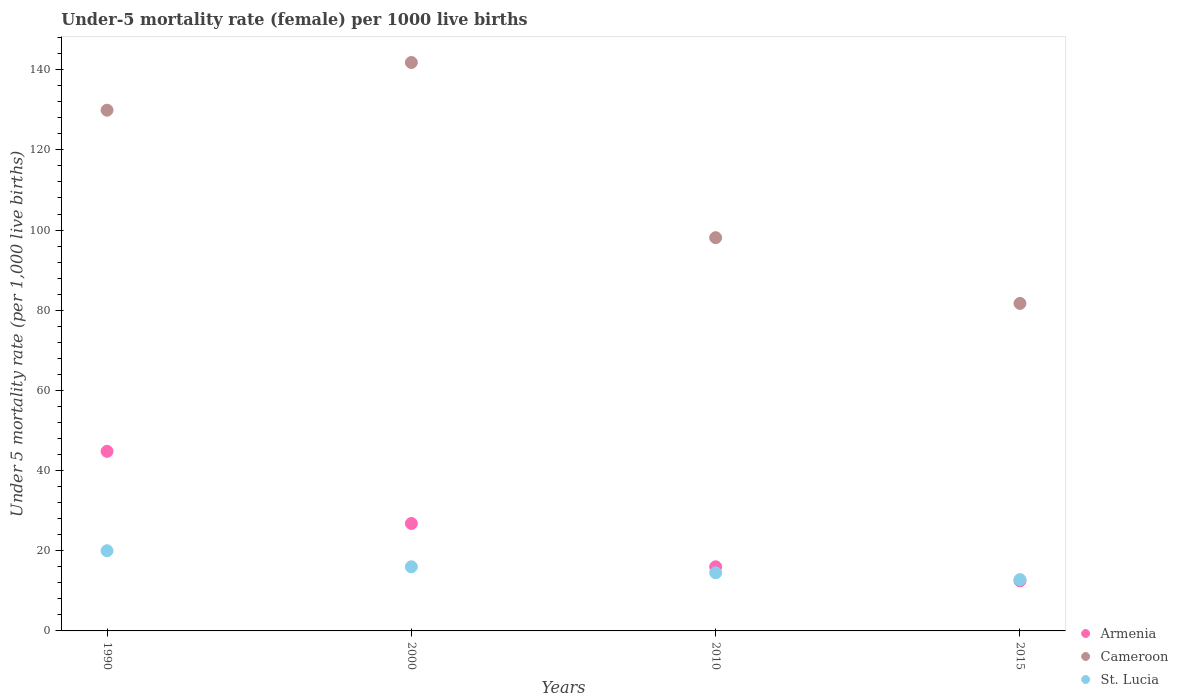Is the number of dotlines equal to the number of legend labels?
Make the answer very short. Yes. What is the under-five mortality rate in Armenia in 2010?
Give a very brief answer. 16. Across all years, what is the maximum under-five mortality rate in Cameroon?
Make the answer very short. 141.8. In which year was the under-five mortality rate in Armenia minimum?
Keep it short and to the point. 2015. What is the total under-five mortality rate in Armenia in the graph?
Your answer should be very brief. 100.1. What is the difference between the under-five mortality rate in St. Lucia in 2000 and that in 2015?
Give a very brief answer. 3.2. What is the difference between the under-five mortality rate in Armenia in 1990 and the under-five mortality rate in Cameroon in 2010?
Offer a terse response. -53.3. What is the average under-five mortality rate in Armenia per year?
Offer a terse response. 25.02. In the year 2010, what is the difference between the under-five mortality rate in Armenia and under-five mortality rate in St. Lucia?
Provide a short and direct response. 1.5. What is the ratio of the under-five mortality rate in Armenia in 2000 to that in 2015?
Make the answer very short. 2.14. What is the difference between the highest and the lowest under-five mortality rate in St. Lucia?
Your answer should be compact. 7.2. In how many years, is the under-five mortality rate in Cameroon greater than the average under-five mortality rate in Cameroon taken over all years?
Your answer should be very brief. 2. Is the sum of the under-five mortality rate in Armenia in 2000 and 2010 greater than the maximum under-five mortality rate in St. Lucia across all years?
Your response must be concise. Yes. Is it the case that in every year, the sum of the under-five mortality rate in St. Lucia and under-five mortality rate in Armenia  is greater than the under-five mortality rate in Cameroon?
Keep it short and to the point. No. Does the under-five mortality rate in St. Lucia monotonically increase over the years?
Give a very brief answer. No. How many years are there in the graph?
Your answer should be very brief. 4. What is the difference between two consecutive major ticks on the Y-axis?
Your answer should be very brief. 20. Does the graph contain any zero values?
Offer a terse response. No. Does the graph contain grids?
Ensure brevity in your answer.  No. Where does the legend appear in the graph?
Offer a very short reply. Bottom right. How are the legend labels stacked?
Offer a very short reply. Vertical. What is the title of the graph?
Offer a very short reply. Under-5 mortality rate (female) per 1000 live births. Does "Nicaragua" appear as one of the legend labels in the graph?
Your response must be concise. No. What is the label or title of the Y-axis?
Your response must be concise. Under 5 mortality rate (per 1,0 live births). What is the Under 5 mortality rate (per 1,000 live births) in Armenia in 1990?
Ensure brevity in your answer.  44.8. What is the Under 5 mortality rate (per 1,000 live births) of Cameroon in 1990?
Ensure brevity in your answer.  129.9. What is the Under 5 mortality rate (per 1,000 live births) of Armenia in 2000?
Provide a short and direct response. 26.8. What is the Under 5 mortality rate (per 1,000 live births) in Cameroon in 2000?
Your answer should be compact. 141.8. What is the Under 5 mortality rate (per 1,000 live births) of St. Lucia in 2000?
Make the answer very short. 16. What is the Under 5 mortality rate (per 1,000 live births) of Armenia in 2010?
Provide a short and direct response. 16. What is the Under 5 mortality rate (per 1,000 live births) in Cameroon in 2010?
Keep it short and to the point. 98.1. What is the Under 5 mortality rate (per 1,000 live births) in Armenia in 2015?
Give a very brief answer. 12.5. What is the Under 5 mortality rate (per 1,000 live births) of Cameroon in 2015?
Your answer should be compact. 81.7. Across all years, what is the maximum Under 5 mortality rate (per 1,000 live births) of Armenia?
Keep it short and to the point. 44.8. Across all years, what is the maximum Under 5 mortality rate (per 1,000 live births) in Cameroon?
Provide a succinct answer. 141.8. Across all years, what is the maximum Under 5 mortality rate (per 1,000 live births) of St. Lucia?
Offer a terse response. 20. Across all years, what is the minimum Under 5 mortality rate (per 1,000 live births) in Armenia?
Your answer should be very brief. 12.5. Across all years, what is the minimum Under 5 mortality rate (per 1,000 live births) of Cameroon?
Provide a short and direct response. 81.7. Across all years, what is the minimum Under 5 mortality rate (per 1,000 live births) in St. Lucia?
Your answer should be compact. 12.8. What is the total Under 5 mortality rate (per 1,000 live births) in Armenia in the graph?
Your answer should be very brief. 100.1. What is the total Under 5 mortality rate (per 1,000 live births) of Cameroon in the graph?
Provide a short and direct response. 451.5. What is the total Under 5 mortality rate (per 1,000 live births) of St. Lucia in the graph?
Offer a terse response. 63.3. What is the difference between the Under 5 mortality rate (per 1,000 live births) in Armenia in 1990 and that in 2010?
Your answer should be compact. 28.8. What is the difference between the Under 5 mortality rate (per 1,000 live births) in Cameroon in 1990 and that in 2010?
Your answer should be very brief. 31.8. What is the difference between the Under 5 mortality rate (per 1,000 live births) in St. Lucia in 1990 and that in 2010?
Make the answer very short. 5.5. What is the difference between the Under 5 mortality rate (per 1,000 live births) of Armenia in 1990 and that in 2015?
Provide a short and direct response. 32.3. What is the difference between the Under 5 mortality rate (per 1,000 live births) in Cameroon in 1990 and that in 2015?
Give a very brief answer. 48.2. What is the difference between the Under 5 mortality rate (per 1,000 live births) of Cameroon in 2000 and that in 2010?
Keep it short and to the point. 43.7. What is the difference between the Under 5 mortality rate (per 1,000 live births) in St. Lucia in 2000 and that in 2010?
Provide a succinct answer. 1.5. What is the difference between the Under 5 mortality rate (per 1,000 live births) in Armenia in 2000 and that in 2015?
Provide a short and direct response. 14.3. What is the difference between the Under 5 mortality rate (per 1,000 live births) in Cameroon in 2000 and that in 2015?
Give a very brief answer. 60.1. What is the difference between the Under 5 mortality rate (per 1,000 live births) in St. Lucia in 2000 and that in 2015?
Keep it short and to the point. 3.2. What is the difference between the Under 5 mortality rate (per 1,000 live births) in Armenia in 2010 and that in 2015?
Make the answer very short. 3.5. What is the difference between the Under 5 mortality rate (per 1,000 live births) of Armenia in 1990 and the Under 5 mortality rate (per 1,000 live births) of Cameroon in 2000?
Your answer should be compact. -97. What is the difference between the Under 5 mortality rate (per 1,000 live births) in Armenia in 1990 and the Under 5 mortality rate (per 1,000 live births) in St. Lucia in 2000?
Make the answer very short. 28.8. What is the difference between the Under 5 mortality rate (per 1,000 live births) in Cameroon in 1990 and the Under 5 mortality rate (per 1,000 live births) in St. Lucia in 2000?
Ensure brevity in your answer.  113.9. What is the difference between the Under 5 mortality rate (per 1,000 live births) in Armenia in 1990 and the Under 5 mortality rate (per 1,000 live births) in Cameroon in 2010?
Provide a short and direct response. -53.3. What is the difference between the Under 5 mortality rate (per 1,000 live births) in Armenia in 1990 and the Under 5 mortality rate (per 1,000 live births) in St. Lucia in 2010?
Ensure brevity in your answer.  30.3. What is the difference between the Under 5 mortality rate (per 1,000 live births) in Cameroon in 1990 and the Under 5 mortality rate (per 1,000 live births) in St. Lucia in 2010?
Offer a terse response. 115.4. What is the difference between the Under 5 mortality rate (per 1,000 live births) of Armenia in 1990 and the Under 5 mortality rate (per 1,000 live births) of Cameroon in 2015?
Offer a very short reply. -36.9. What is the difference between the Under 5 mortality rate (per 1,000 live births) in Armenia in 1990 and the Under 5 mortality rate (per 1,000 live births) in St. Lucia in 2015?
Make the answer very short. 32. What is the difference between the Under 5 mortality rate (per 1,000 live births) in Cameroon in 1990 and the Under 5 mortality rate (per 1,000 live births) in St. Lucia in 2015?
Your answer should be compact. 117.1. What is the difference between the Under 5 mortality rate (per 1,000 live births) of Armenia in 2000 and the Under 5 mortality rate (per 1,000 live births) of Cameroon in 2010?
Your answer should be compact. -71.3. What is the difference between the Under 5 mortality rate (per 1,000 live births) in Cameroon in 2000 and the Under 5 mortality rate (per 1,000 live births) in St. Lucia in 2010?
Offer a very short reply. 127.3. What is the difference between the Under 5 mortality rate (per 1,000 live births) in Armenia in 2000 and the Under 5 mortality rate (per 1,000 live births) in Cameroon in 2015?
Offer a very short reply. -54.9. What is the difference between the Under 5 mortality rate (per 1,000 live births) of Armenia in 2000 and the Under 5 mortality rate (per 1,000 live births) of St. Lucia in 2015?
Your answer should be very brief. 14. What is the difference between the Under 5 mortality rate (per 1,000 live births) in Cameroon in 2000 and the Under 5 mortality rate (per 1,000 live births) in St. Lucia in 2015?
Your answer should be very brief. 129. What is the difference between the Under 5 mortality rate (per 1,000 live births) of Armenia in 2010 and the Under 5 mortality rate (per 1,000 live births) of Cameroon in 2015?
Your answer should be very brief. -65.7. What is the difference between the Under 5 mortality rate (per 1,000 live births) of Cameroon in 2010 and the Under 5 mortality rate (per 1,000 live births) of St. Lucia in 2015?
Offer a very short reply. 85.3. What is the average Under 5 mortality rate (per 1,000 live births) in Armenia per year?
Offer a terse response. 25.02. What is the average Under 5 mortality rate (per 1,000 live births) of Cameroon per year?
Keep it short and to the point. 112.88. What is the average Under 5 mortality rate (per 1,000 live births) of St. Lucia per year?
Make the answer very short. 15.82. In the year 1990, what is the difference between the Under 5 mortality rate (per 1,000 live births) in Armenia and Under 5 mortality rate (per 1,000 live births) in Cameroon?
Offer a terse response. -85.1. In the year 1990, what is the difference between the Under 5 mortality rate (per 1,000 live births) of Armenia and Under 5 mortality rate (per 1,000 live births) of St. Lucia?
Keep it short and to the point. 24.8. In the year 1990, what is the difference between the Under 5 mortality rate (per 1,000 live births) in Cameroon and Under 5 mortality rate (per 1,000 live births) in St. Lucia?
Offer a terse response. 109.9. In the year 2000, what is the difference between the Under 5 mortality rate (per 1,000 live births) of Armenia and Under 5 mortality rate (per 1,000 live births) of Cameroon?
Give a very brief answer. -115. In the year 2000, what is the difference between the Under 5 mortality rate (per 1,000 live births) in Armenia and Under 5 mortality rate (per 1,000 live births) in St. Lucia?
Offer a very short reply. 10.8. In the year 2000, what is the difference between the Under 5 mortality rate (per 1,000 live births) of Cameroon and Under 5 mortality rate (per 1,000 live births) of St. Lucia?
Make the answer very short. 125.8. In the year 2010, what is the difference between the Under 5 mortality rate (per 1,000 live births) of Armenia and Under 5 mortality rate (per 1,000 live births) of Cameroon?
Offer a very short reply. -82.1. In the year 2010, what is the difference between the Under 5 mortality rate (per 1,000 live births) in Armenia and Under 5 mortality rate (per 1,000 live births) in St. Lucia?
Ensure brevity in your answer.  1.5. In the year 2010, what is the difference between the Under 5 mortality rate (per 1,000 live births) in Cameroon and Under 5 mortality rate (per 1,000 live births) in St. Lucia?
Your response must be concise. 83.6. In the year 2015, what is the difference between the Under 5 mortality rate (per 1,000 live births) in Armenia and Under 5 mortality rate (per 1,000 live births) in Cameroon?
Ensure brevity in your answer.  -69.2. In the year 2015, what is the difference between the Under 5 mortality rate (per 1,000 live births) in Cameroon and Under 5 mortality rate (per 1,000 live births) in St. Lucia?
Offer a terse response. 68.9. What is the ratio of the Under 5 mortality rate (per 1,000 live births) of Armenia in 1990 to that in 2000?
Make the answer very short. 1.67. What is the ratio of the Under 5 mortality rate (per 1,000 live births) of Cameroon in 1990 to that in 2000?
Offer a very short reply. 0.92. What is the ratio of the Under 5 mortality rate (per 1,000 live births) of Cameroon in 1990 to that in 2010?
Ensure brevity in your answer.  1.32. What is the ratio of the Under 5 mortality rate (per 1,000 live births) in St. Lucia in 1990 to that in 2010?
Offer a very short reply. 1.38. What is the ratio of the Under 5 mortality rate (per 1,000 live births) of Armenia in 1990 to that in 2015?
Offer a terse response. 3.58. What is the ratio of the Under 5 mortality rate (per 1,000 live births) of Cameroon in 1990 to that in 2015?
Your response must be concise. 1.59. What is the ratio of the Under 5 mortality rate (per 1,000 live births) of St. Lucia in 1990 to that in 2015?
Offer a very short reply. 1.56. What is the ratio of the Under 5 mortality rate (per 1,000 live births) in Armenia in 2000 to that in 2010?
Give a very brief answer. 1.68. What is the ratio of the Under 5 mortality rate (per 1,000 live births) of Cameroon in 2000 to that in 2010?
Give a very brief answer. 1.45. What is the ratio of the Under 5 mortality rate (per 1,000 live births) of St. Lucia in 2000 to that in 2010?
Provide a short and direct response. 1.1. What is the ratio of the Under 5 mortality rate (per 1,000 live births) of Armenia in 2000 to that in 2015?
Give a very brief answer. 2.14. What is the ratio of the Under 5 mortality rate (per 1,000 live births) of Cameroon in 2000 to that in 2015?
Offer a terse response. 1.74. What is the ratio of the Under 5 mortality rate (per 1,000 live births) in St. Lucia in 2000 to that in 2015?
Ensure brevity in your answer.  1.25. What is the ratio of the Under 5 mortality rate (per 1,000 live births) in Armenia in 2010 to that in 2015?
Make the answer very short. 1.28. What is the ratio of the Under 5 mortality rate (per 1,000 live births) of Cameroon in 2010 to that in 2015?
Your answer should be very brief. 1.2. What is the ratio of the Under 5 mortality rate (per 1,000 live births) of St. Lucia in 2010 to that in 2015?
Make the answer very short. 1.13. What is the difference between the highest and the second highest Under 5 mortality rate (per 1,000 live births) of St. Lucia?
Offer a terse response. 4. What is the difference between the highest and the lowest Under 5 mortality rate (per 1,000 live births) of Armenia?
Provide a short and direct response. 32.3. What is the difference between the highest and the lowest Under 5 mortality rate (per 1,000 live births) in Cameroon?
Your answer should be very brief. 60.1. What is the difference between the highest and the lowest Under 5 mortality rate (per 1,000 live births) of St. Lucia?
Your answer should be very brief. 7.2. 